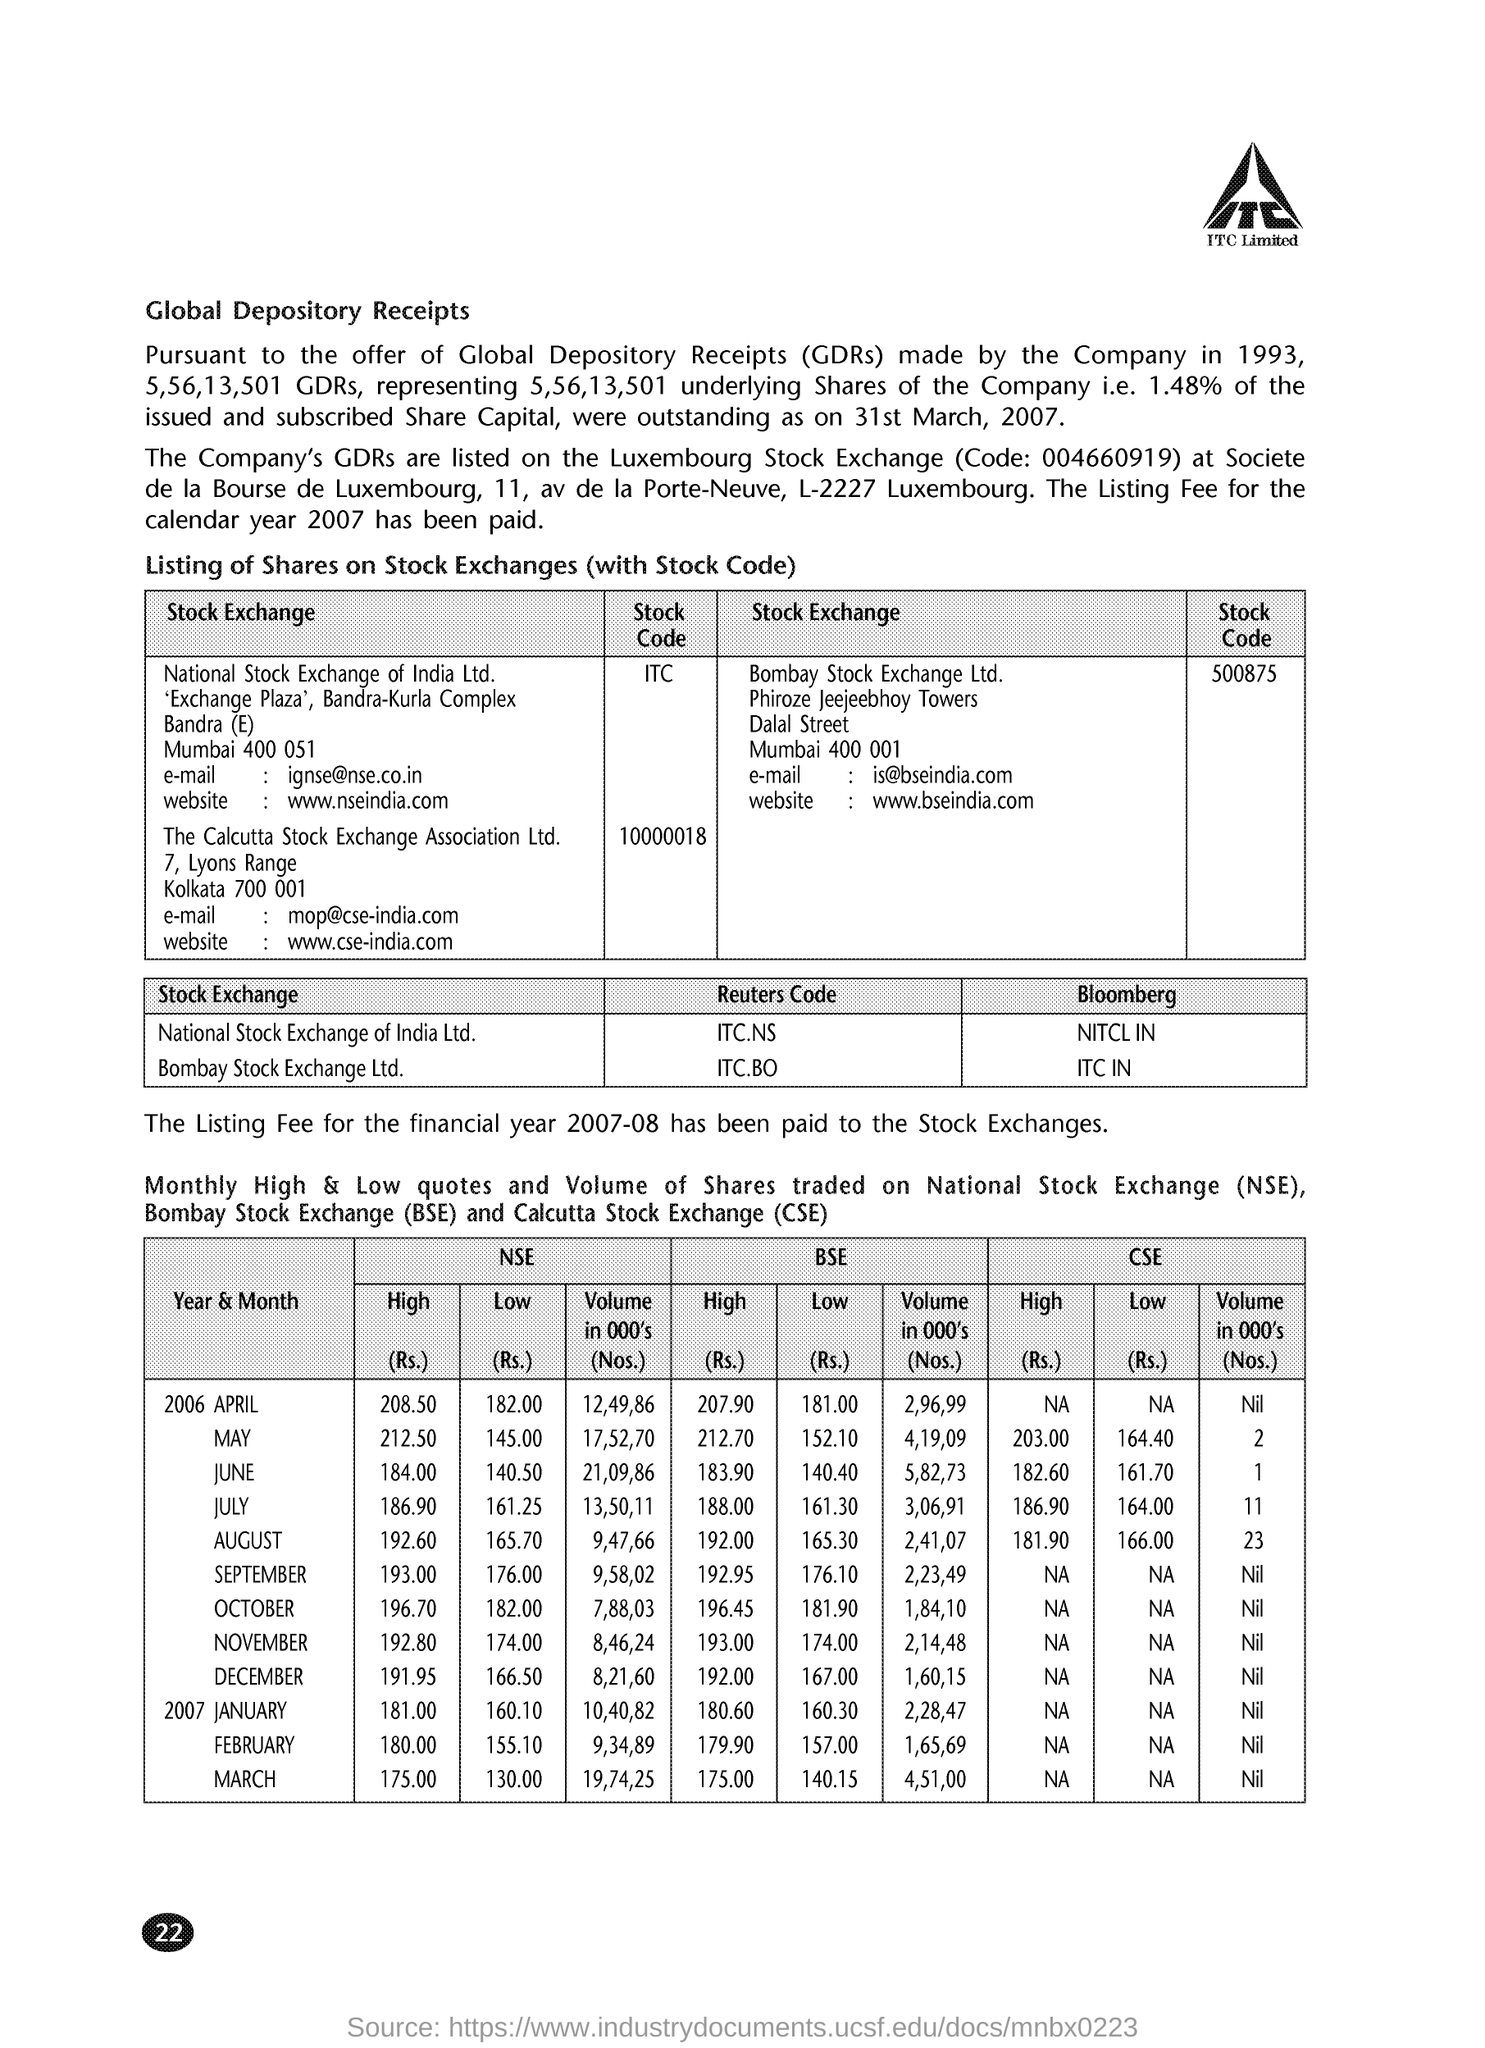List a handful of essential elements in this visual. The email address for Calcutta Stock Exchange Association Limited is [mop@cse-india.com](mailto:mop@cse-india.com). On July 2006, the high price of CSE was 186.90. On April 2006, the high price of NSE was 208.50. The Bombay Stock Exchange Limited's stock code is 500875. The full form of CSE is Calcutta Stock Exchange. 